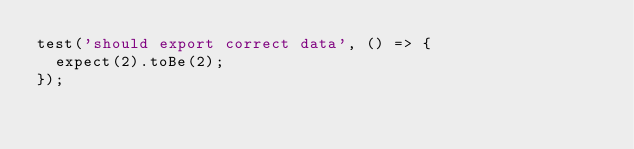Convert code to text. <code><loc_0><loc_0><loc_500><loc_500><_JavaScript_>test('should export correct data', () => {
  expect(2).toBe(2);
});
</code> 